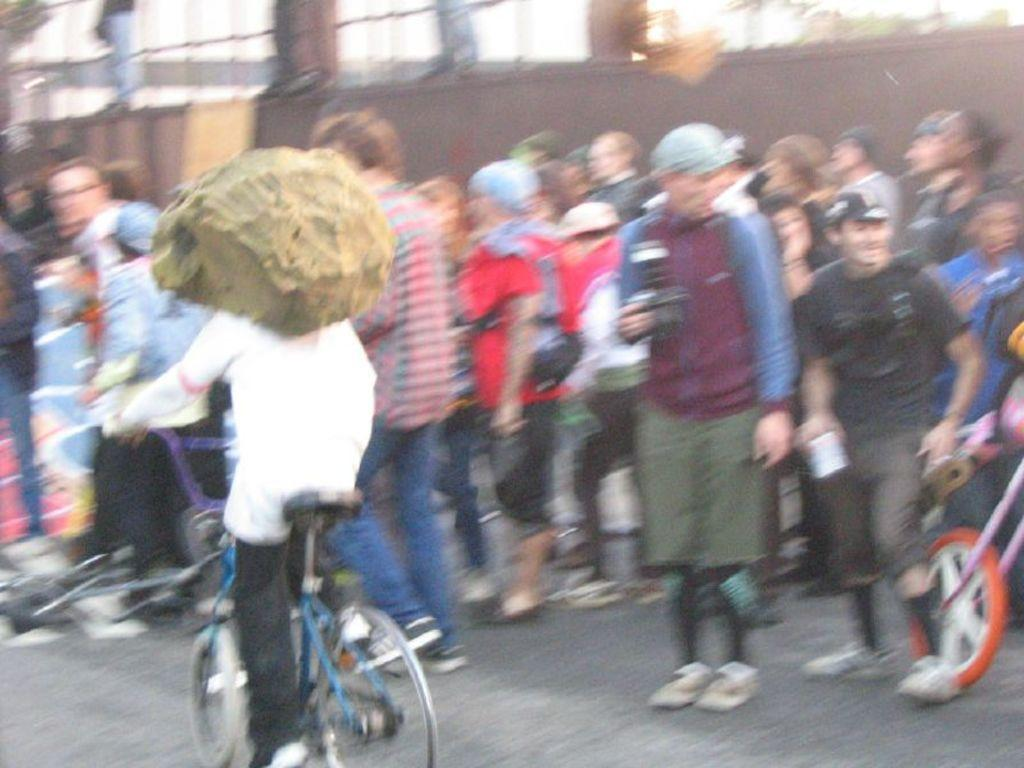What are the persons in the image doing? There are persons standing and cycling in the image. What can be seen in the background of the image? There is a wall in the background of the image. What type of bone is visible in the image? There is no bone present in the image; it features persons standing and cycling with a wall in the background. 